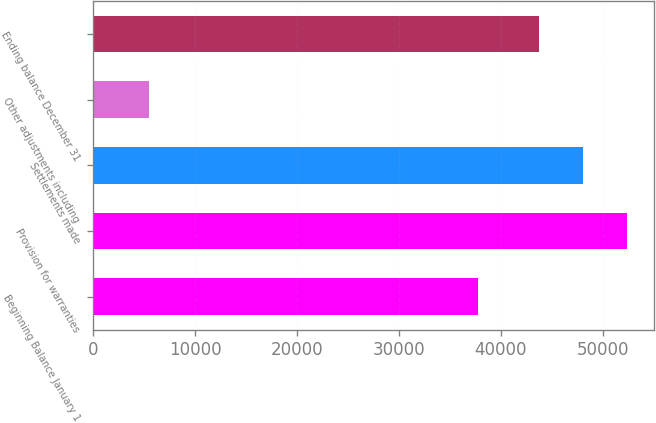Convert chart. <chart><loc_0><loc_0><loc_500><loc_500><bar_chart><fcel>Beginning Balance January 1<fcel>Provision for warranties<fcel>Settlements made<fcel>Other adjustments including<fcel>Ending balance December 31<nl><fcel>37739<fcel>52400.6<fcel>48086<fcel>5480<fcel>43759<nl></chart> 